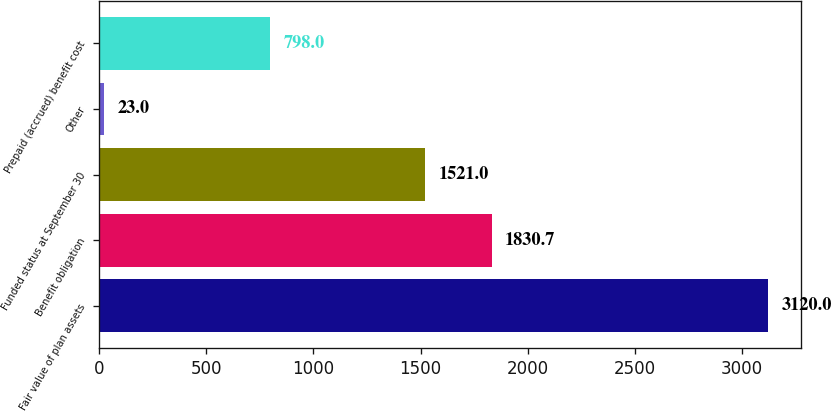<chart> <loc_0><loc_0><loc_500><loc_500><bar_chart><fcel>Fair value of plan assets<fcel>Benefit obligation<fcel>Funded status at September 30<fcel>Other<fcel>Prepaid (accrued) benefit cost<nl><fcel>3120<fcel>1830.7<fcel>1521<fcel>23<fcel>798<nl></chart> 